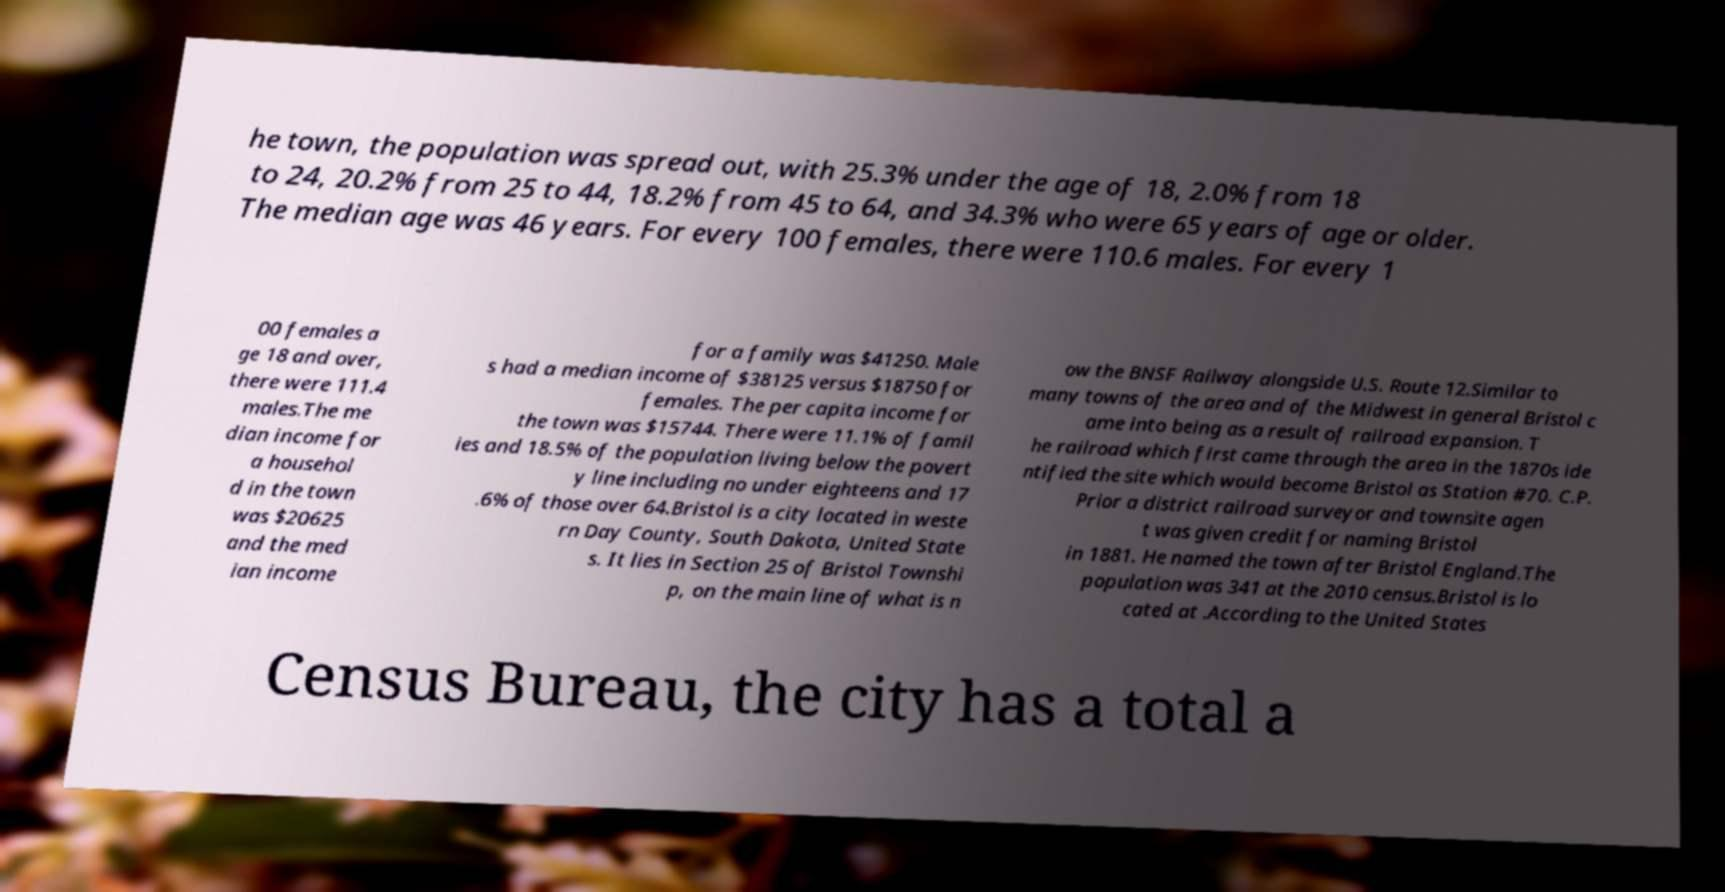There's text embedded in this image that I need extracted. Can you transcribe it verbatim? he town, the population was spread out, with 25.3% under the age of 18, 2.0% from 18 to 24, 20.2% from 25 to 44, 18.2% from 45 to 64, and 34.3% who were 65 years of age or older. The median age was 46 years. For every 100 females, there were 110.6 males. For every 1 00 females a ge 18 and over, there were 111.4 males.The me dian income for a househol d in the town was $20625 and the med ian income for a family was $41250. Male s had a median income of $38125 versus $18750 for females. The per capita income for the town was $15744. There were 11.1% of famil ies and 18.5% of the population living below the povert y line including no under eighteens and 17 .6% of those over 64.Bristol is a city located in weste rn Day County, South Dakota, United State s. It lies in Section 25 of Bristol Townshi p, on the main line of what is n ow the BNSF Railway alongside U.S. Route 12.Similar to many towns of the area and of the Midwest in general Bristol c ame into being as a result of railroad expansion. T he railroad which first came through the area in the 1870s ide ntified the site which would become Bristol as Station #70. C.P. Prior a district railroad surveyor and townsite agen t was given credit for naming Bristol in 1881. He named the town after Bristol England.The population was 341 at the 2010 census.Bristol is lo cated at .According to the United States Census Bureau, the city has a total a 